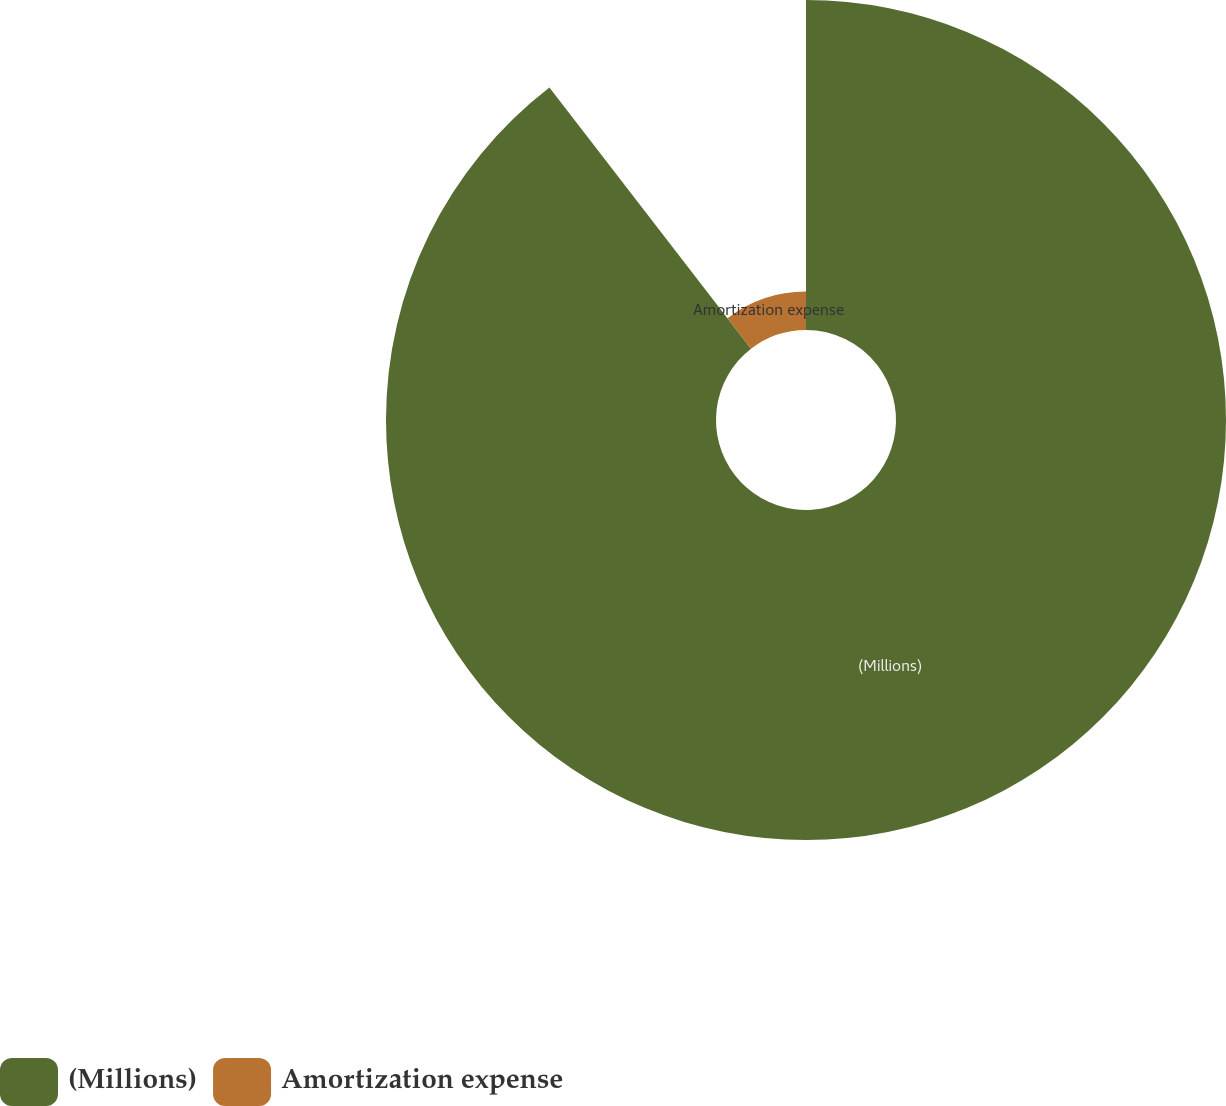Convert chart to OTSL. <chart><loc_0><loc_0><loc_500><loc_500><pie_chart><fcel>(Millions)<fcel>Amortization expense<nl><fcel>89.54%<fcel>10.46%<nl></chart> 